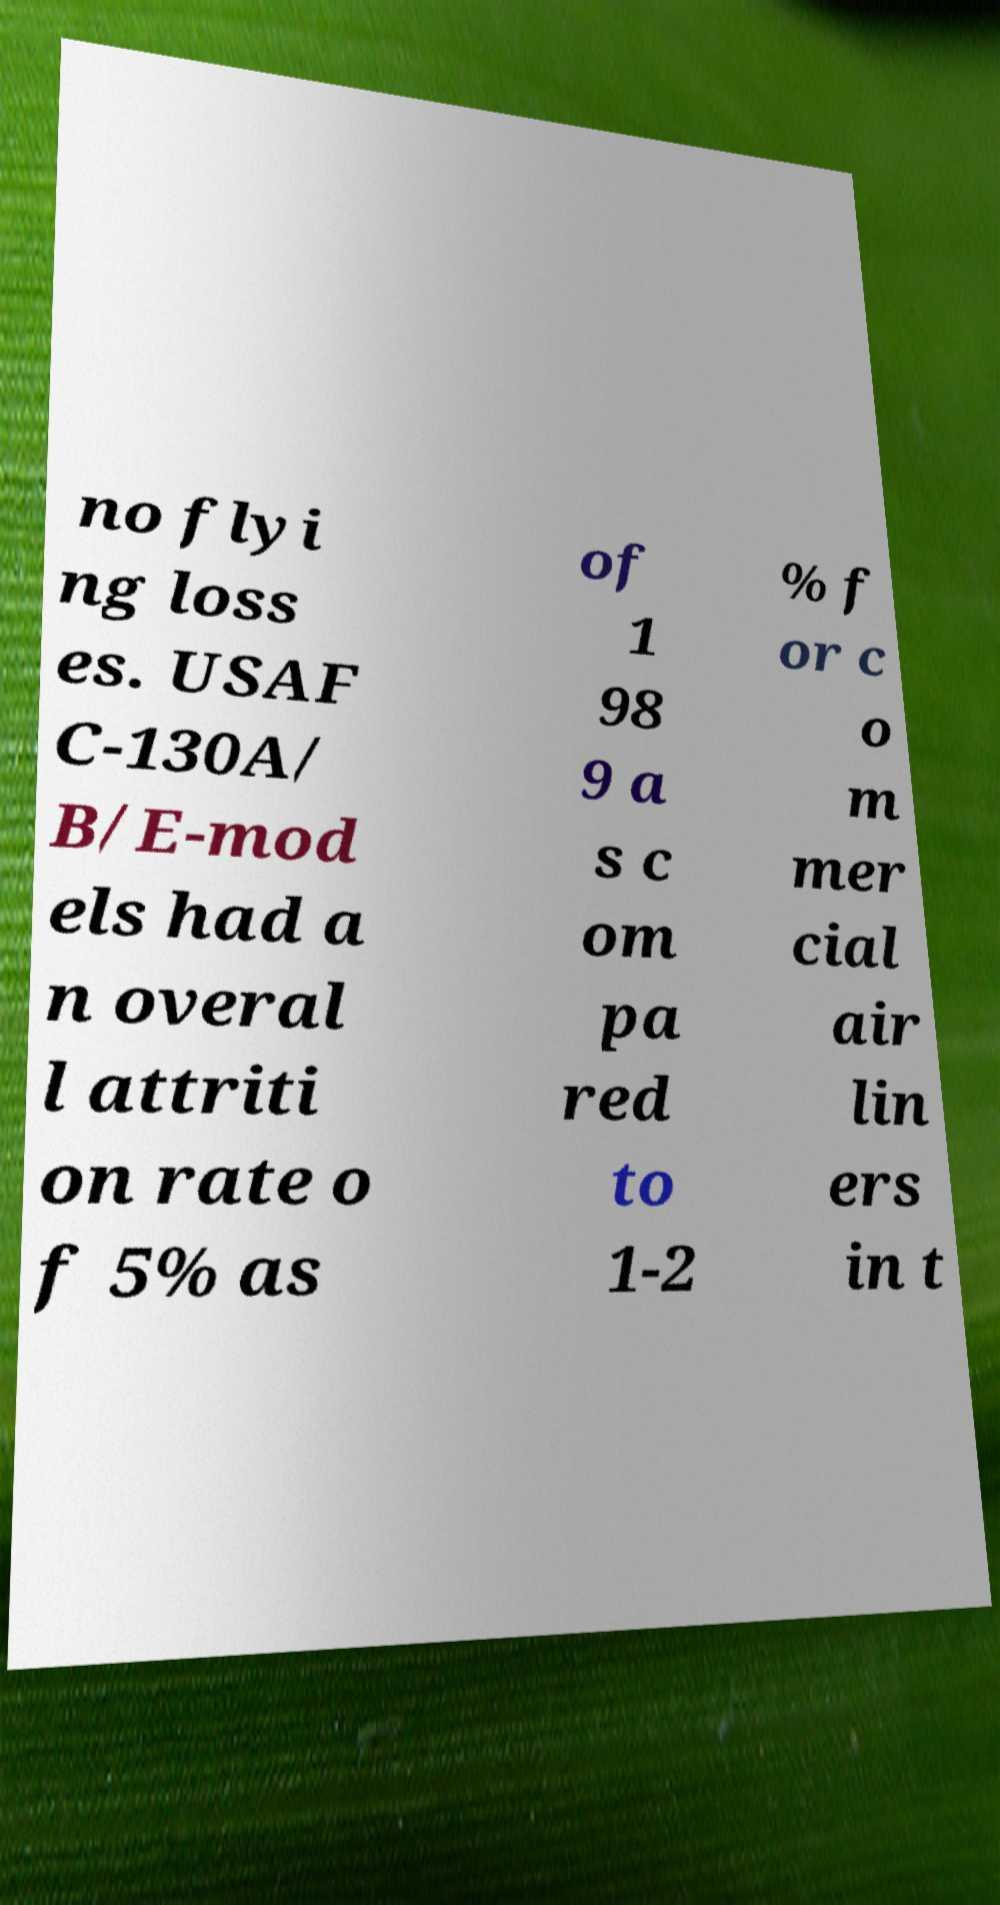Could you extract and type out the text from this image? no flyi ng loss es. USAF C-130A/ B/E-mod els had a n overal l attriti on rate o f 5% as of 1 98 9 a s c om pa red to 1-2 % f or c o m mer cial air lin ers in t 